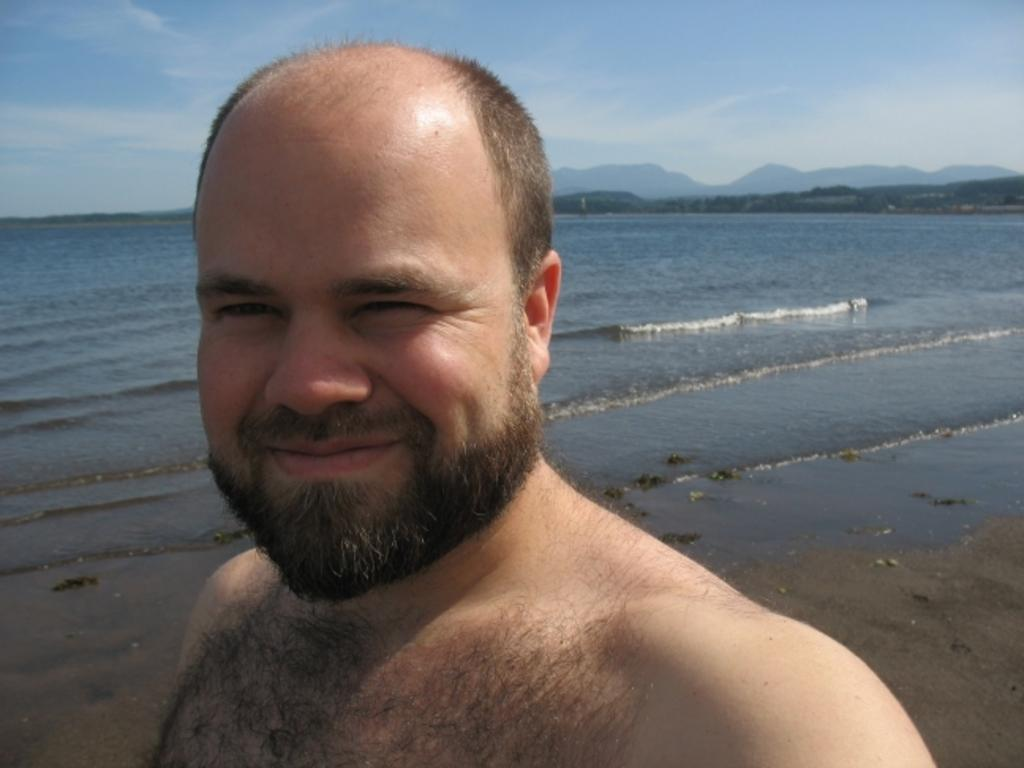What type of location might the image have been taken at? The image might have been taken at a beach. What can be seen in the middle of the image? There is water in the middle of the image. Who is in the front of the image? There is a person in the front of the image. What expression does the person have? The person is smiling. What is visible at the top of the image? The sky is visible at the top of the image. How many oranges can be seen in the image? There are no oranges present in the image. Is the person's grandmother visible in the image? There is no mention of a grandmother in the image, and no such person is visible. 